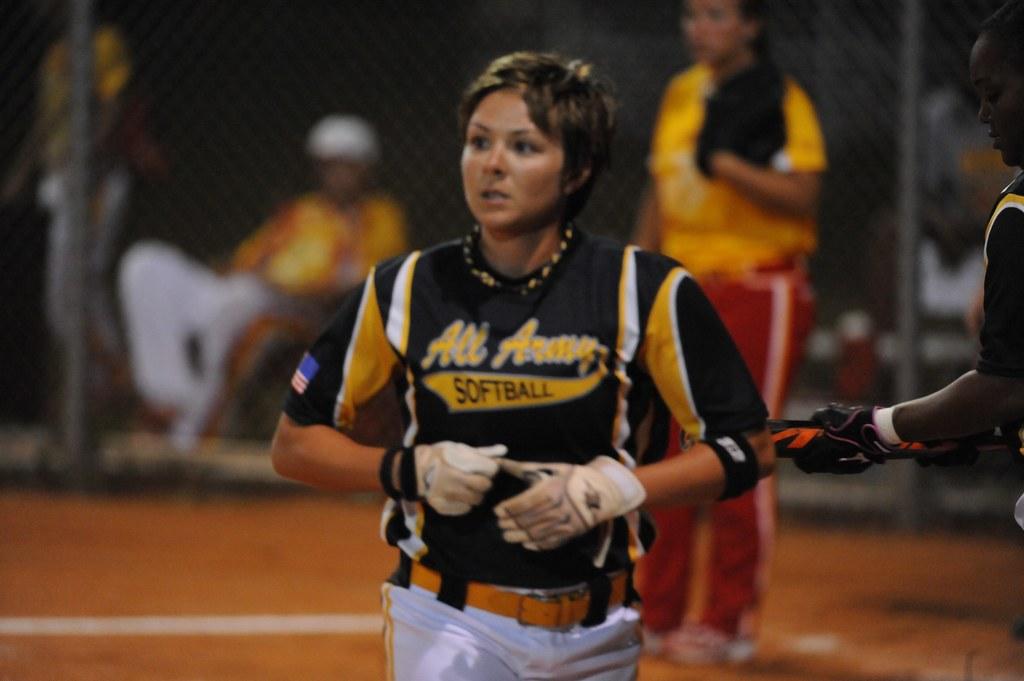What sport is on this girls shirt?
Make the answer very short. Softball. Is the word "all" on the jersey?
Make the answer very short. Yes. 